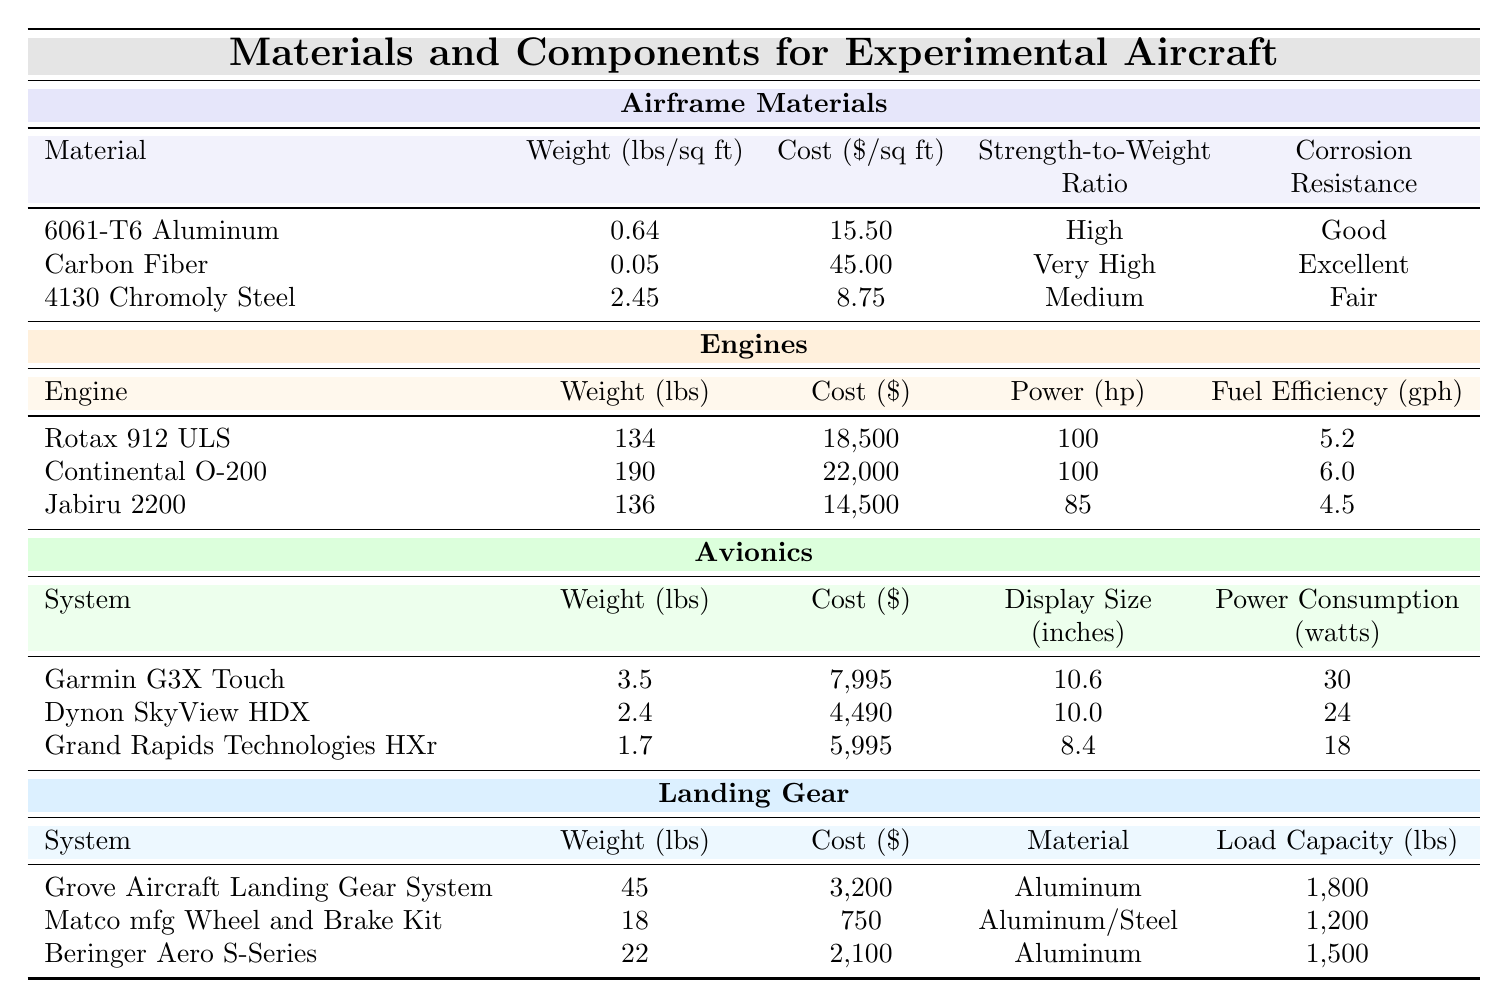What is the weight of Carbon Fiber in lbs/sq ft? The table lists Carbon Fiber under the "Airframe Materials" category, where its weight is specified as 0.05 lbs/sq ft.
Answer: 0.05 lbs/sq ft Which engine has the highest weight? By comparing the weights of the engines listed, Rotax 912 ULS is 134 lbs, Continental O-200 is 190 lbs, and Jabiru 2200 is 136 lbs. The highest weight is 190 lbs.
Answer: Continental O-200 What is the combined weight of all airframe materials? The weights of the airframe materials are 0.64 lbs/sq ft for 6061-T6 Aluminum, 0.05 lbs/sq ft for Carbon Fiber, and 2.45 lbs/sq ft for 4130 Chromoly Steel. Adding these gives 0.64 + 0.05 + 2.45 = 3.14 lbs/sq ft.
Answer: 3.14 lbs/sq ft Is the strength-to-weight ratio of 4130 Chromoly Steel considered high? The table categorizes the strength-to-weight ratio of 4130 Chromoly Steel as "Medium," which is less than high.
Answer: No What is the total cost of all engines combined? The costs of the engines are $18,500 for Rotax 912 ULS, $22,000 for Continental O-200, and $14,500 for Jabiru 2200. Adding these together gives $18,500 + $22,000 + $14,500 = $55,000.
Answer: $55,000 Which avionics system has the largest display size? By checking the display sizes, Garmin G3X Touch has a size of 10.6 inches, Dynon SkyView HDX has 10.0 inches, and Grand Rapids Technologies HXr has 8.4 inches. The largest display size is 10.6 inches.
Answer: Garmin G3X Touch Is the cost of the Grove Aircraft Landing Gear System less than $4,000? The table shows that the cost of Grove Aircraft Landing Gear System is $3,200, which is less than $4,000.
Answer: Yes What is the average weight of all landing gear systems? The weights of the landing gear systems are 45 lbs for Grove, 18 lbs for Matco, and 22 lbs for Beringer. The total weight is 45 + 18 + 22 = 85 lbs. There are three systems, so the average is 85 / 3 = 28.33 lbs.
Answer: 28.33 lbs Which material has excellent corrosion resistance? The table indicates that Carbon Fiber has "Excellent" corrosion resistance listed under airframe materials.
Answer: Carbon Fiber How many avionics systems weigh less than 3 lbs? The weights of the avionics systems are 3.5 lbs for Garmin G3X Touch, 2.4 lbs for Dynon SkyView HDX, and 1.7 lbs for Grand Rapids Technologies HXr. Only Dynon SkyView HDX and Grand Rapids Technologies HXr weigh less than 3 lbs, which is two systems.
Answer: 2 systems Which material in landing gear has the lowest cost? Comparing the costs, Grove Aircraft Landing Gear System is $3,200, Matco mfg Wheel and Brake Kit is $750, and Beringer Aero S-Series is $2,100. The lowest cost is $750 for Matco mfg Wheel and Brake Kit.
Answer: Matco mfg Wheel and Brake Kit 